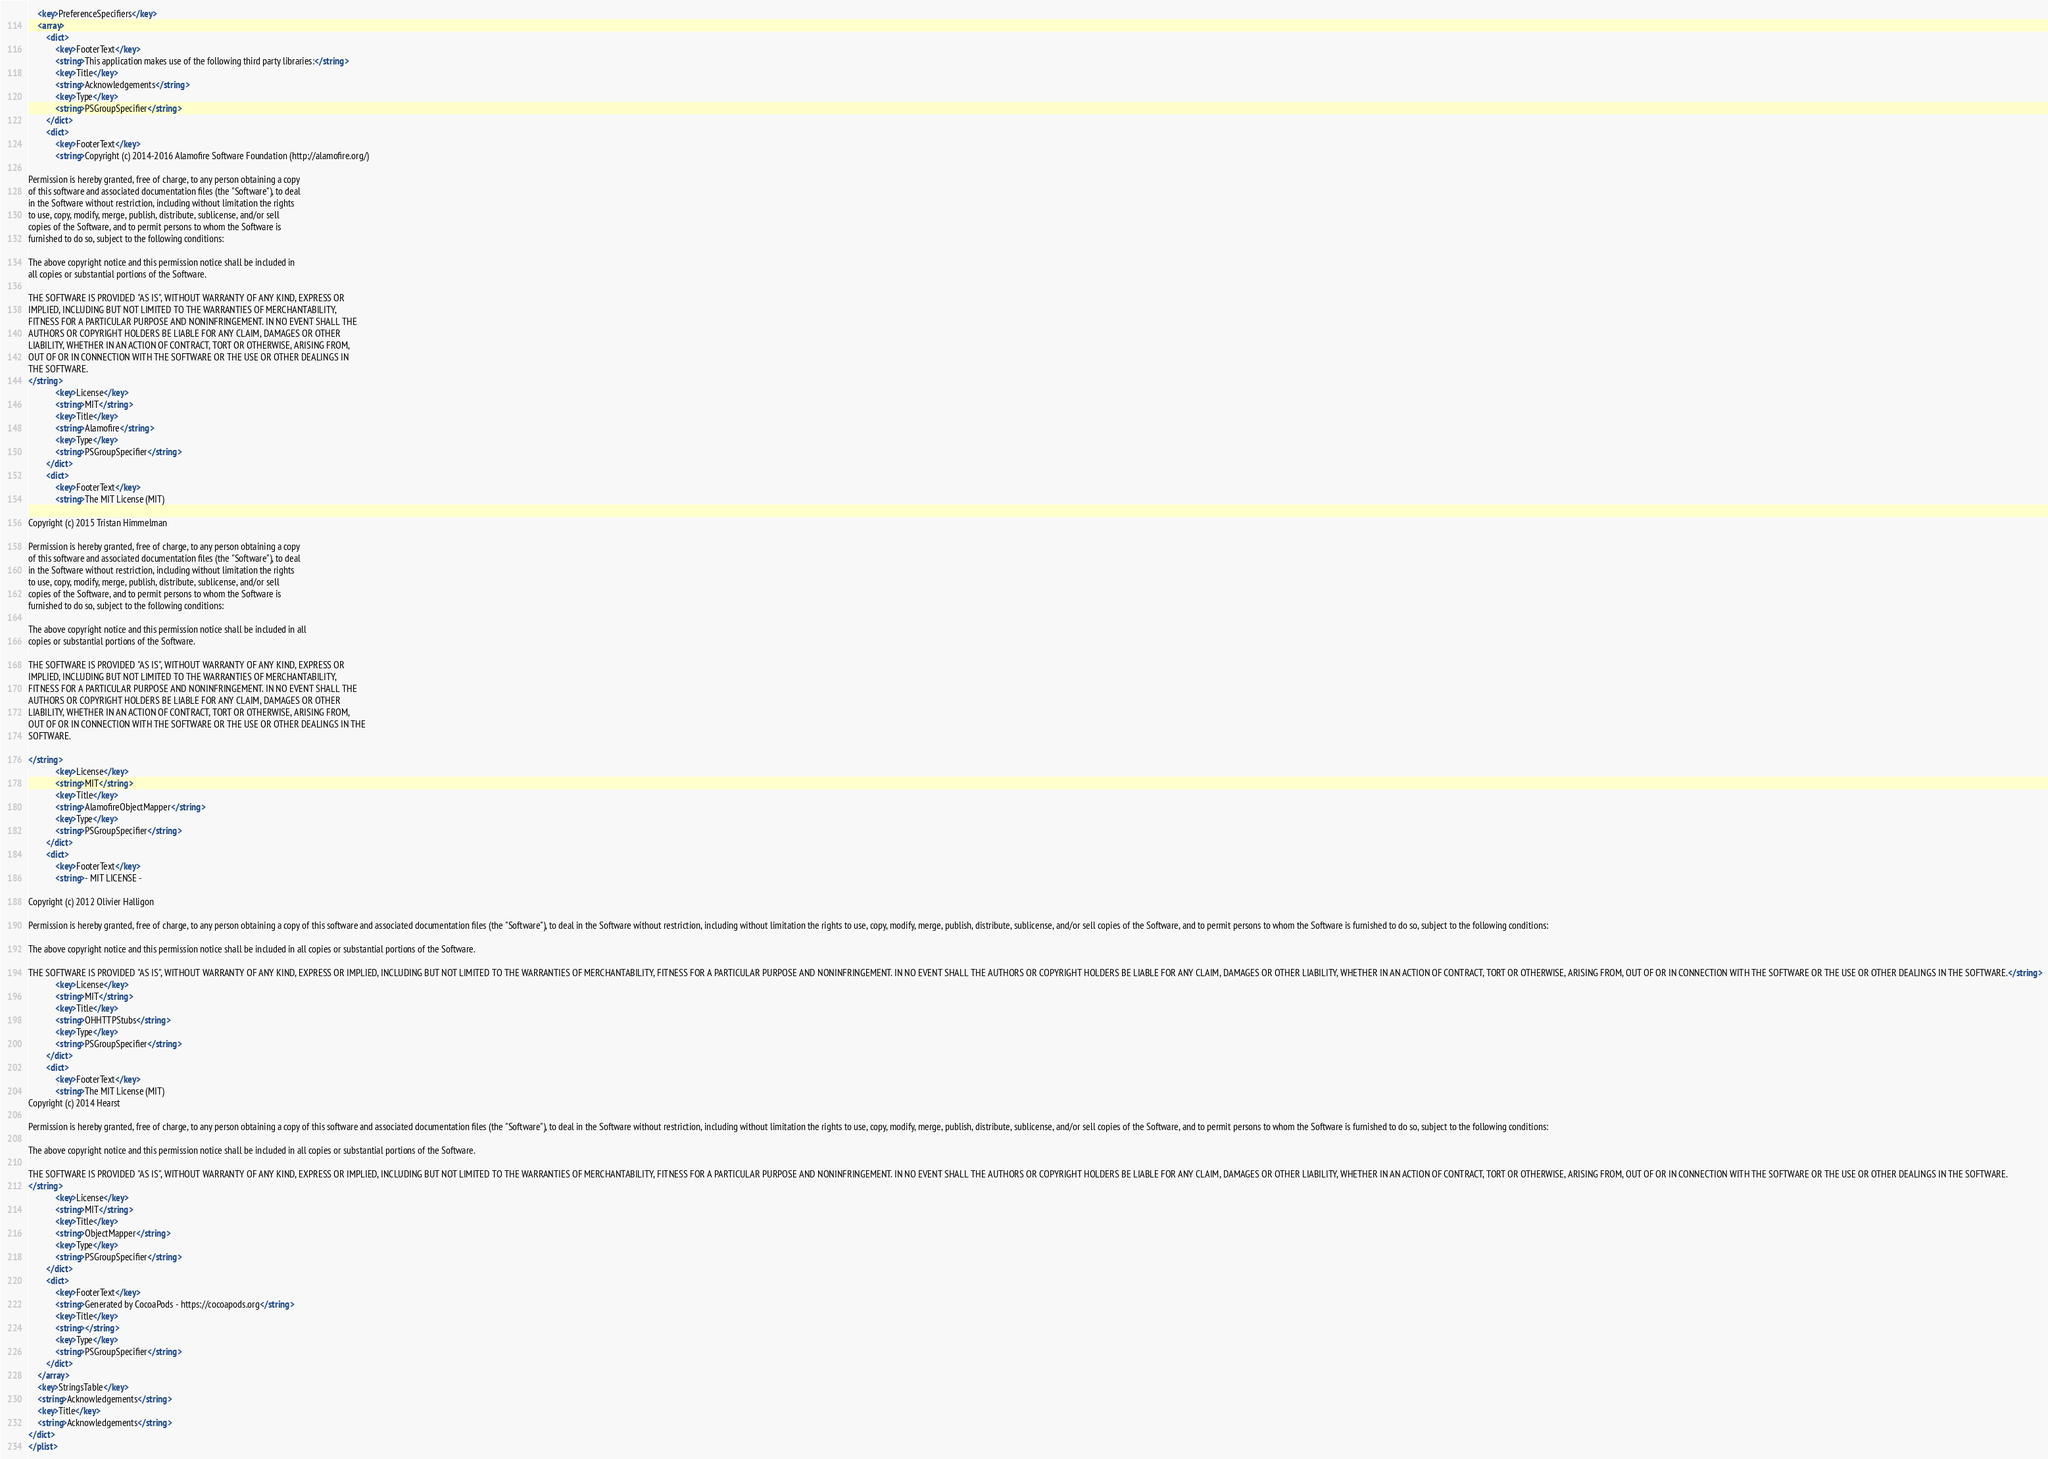Convert code to text. <code><loc_0><loc_0><loc_500><loc_500><_XML_>	<key>PreferenceSpecifiers</key>
	<array>
		<dict>
			<key>FooterText</key>
			<string>This application makes use of the following third party libraries:</string>
			<key>Title</key>
			<string>Acknowledgements</string>
			<key>Type</key>
			<string>PSGroupSpecifier</string>
		</dict>
		<dict>
			<key>FooterText</key>
			<string>Copyright (c) 2014-2016 Alamofire Software Foundation (http://alamofire.org/)

Permission is hereby granted, free of charge, to any person obtaining a copy
of this software and associated documentation files (the "Software"), to deal
in the Software without restriction, including without limitation the rights
to use, copy, modify, merge, publish, distribute, sublicense, and/or sell
copies of the Software, and to permit persons to whom the Software is
furnished to do so, subject to the following conditions:

The above copyright notice and this permission notice shall be included in
all copies or substantial portions of the Software.

THE SOFTWARE IS PROVIDED "AS IS", WITHOUT WARRANTY OF ANY KIND, EXPRESS OR
IMPLIED, INCLUDING BUT NOT LIMITED TO THE WARRANTIES OF MERCHANTABILITY,
FITNESS FOR A PARTICULAR PURPOSE AND NONINFRINGEMENT. IN NO EVENT SHALL THE
AUTHORS OR COPYRIGHT HOLDERS BE LIABLE FOR ANY CLAIM, DAMAGES OR OTHER
LIABILITY, WHETHER IN AN ACTION OF CONTRACT, TORT OR OTHERWISE, ARISING FROM,
OUT OF OR IN CONNECTION WITH THE SOFTWARE OR THE USE OR OTHER DEALINGS IN
THE SOFTWARE.
</string>
			<key>License</key>
			<string>MIT</string>
			<key>Title</key>
			<string>Alamofire</string>
			<key>Type</key>
			<string>PSGroupSpecifier</string>
		</dict>
		<dict>
			<key>FooterText</key>
			<string>The MIT License (MIT)

Copyright (c) 2015 Tristan Himmelman

Permission is hereby granted, free of charge, to any person obtaining a copy
of this software and associated documentation files (the "Software"), to deal
in the Software without restriction, including without limitation the rights
to use, copy, modify, merge, publish, distribute, sublicense, and/or sell
copies of the Software, and to permit persons to whom the Software is
furnished to do so, subject to the following conditions:

The above copyright notice and this permission notice shall be included in all
copies or substantial portions of the Software.

THE SOFTWARE IS PROVIDED "AS IS", WITHOUT WARRANTY OF ANY KIND, EXPRESS OR
IMPLIED, INCLUDING BUT NOT LIMITED TO THE WARRANTIES OF MERCHANTABILITY,
FITNESS FOR A PARTICULAR PURPOSE AND NONINFRINGEMENT. IN NO EVENT SHALL THE
AUTHORS OR COPYRIGHT HOLDERS BE LIABLE FOR ANY CLAIM, DAMAGES OR OTHER
LIABILITY, WHETHER IN AN ACTION OF CONTRACT, TORT OR OTHERWISE, ARISING FROM,
OUT OF OR IN CONNECTION WITH THE SOFTWARE OR THE USE OR OTHER DEALINGS IN THE
SOFTWARE.

</string>
			<key>License</key>
			<string>MIT</string>
			<key>Title</key>
			<string>AlamofireObjectMapper</string>
			<key>Type</key>
			<string>PSGroupSpecifier</string>
		</dict>
		<dict>
			<key>FooterText</key>
			<string>- MIT LICENSE -

Copyright (c) 2012 Olivier Halligon

Permission is hereby granted, free of charge, to any person obtaining a copy of this software and associated documentation files (the "Software"), to deal in the Software without restriction, including without limitation the rights to use, copy, modify, merge, publish, distribute, sublicense, and/or sell copies of the Software, and to permit persons to whom the Software is furnished to do so, subject to the following conditions:

The above copyright notice and this permission notice shall be included in all copies or substantial portions of the Software.

THE SOFTWARE IS PROVIDED "AS IS", WITHOUT WARRANTY OF ANY KIND, EXPRESS OR IMPLIED, INCLUDING BUT NOT LIMITED TO THE WARRANTIES OF MERCHANTABILITY, FITNESS FOR A PARTICULAR PURPOSE AND NONINFRINGEMENT. IN NO EVENT SHALL THE AUTHORS OR COPYRIGHT HOLDERS BE LIABLE FOR ANY CLAIM, DAMAGES OR OTHER LIABILITY, WHETHER IN AN ACTION OF CONTRACT, TORT OR OTHERWISE, ARISING FROM, OUT OF OR IN CONNECTION WITH THE SOFTWARE OR THE USE OR OTHER DEALINGS IN THE SOFTWARE.</string>
			<key>License</key>
			<string>MIT</string>
			<key>Title</key>
			<string>OHHTTPStubs</string>
			<key>Type</key>
			<string>PSGroupSpecifier</string>
		</dict>
		<dict>
			<key>FooterText</key>
			<string>The MIT License (MIT)
Copyright (c) 2014 Hearst

Permission is hereby granted, free of charge, to any person obtaining a copy of this software and associated documentation files (the "Software"), to deal in the Software without restriction, including without limitation the rights to use, copy, modify, merge, publish, distribute, sublicense, and/or sell copies of the Software, and to permit persons to whom the Software is furnished to do so, subject to the following conditions:

The above copyright notice and this permission notice shall be included in all copies or substantial portions of the Software.

THE SOFTWARE IS PROVIDED "AS IS", WITHOUT WARRANTY OF ANY KIND, EXPRESS OR IMPLIED, INCLUDING BUT NOT LIMITED TO THE WARRANTIES OF MERCHANTABILITY, FITNESS FOR A PARTICULAR PURPOSE AND NONINFRINGEMENT. IN NO EVENT SHALL THE AUTHORS OR COPYRIGHT HOLDERS BE LIABLE FOR ANY CLAIM, DAMAGES OR OTHER LIABILITY, WHETHER IN AN ACTION OF CONTRACT, TORT OR OTHERWISE, ARISING FROM, OUT OF OR IN CONNECTION WITH THE SOFTWARE OR THE USE OR OTHER DEALINGS IN THE SOFTWARE.
</string>
			<key>License</key>
			<string>MIT</string>
			<key>Title</key>
			<string>ObjectMapper</string>
			<key>Type</key>
			<string>PSGroupSpecifier</string>
		</dict>
		<dict>
			<key>FooterText</key>
			<string>Generated by CocoaPods - https://cocoapods.org</string>
			<key>Title</key>
			<string></string>
			<key>Type</key>
			<string>PSGroupSpecifier</string>
		</dict>
	</array>
	<key>StringsTable</key>
	<string>Acknowledgements</string>
	<key>Title</key>
	<string>Acknowledgements</string>
</dict>
</plist>
</code> 